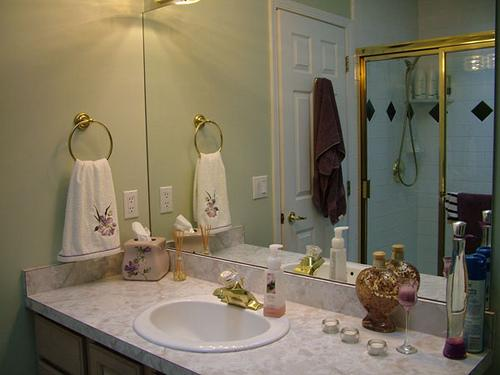What color is the faucet above of the sink? Please explain your reasoning. yellow. It has a tinge of the primary colour of yellow 